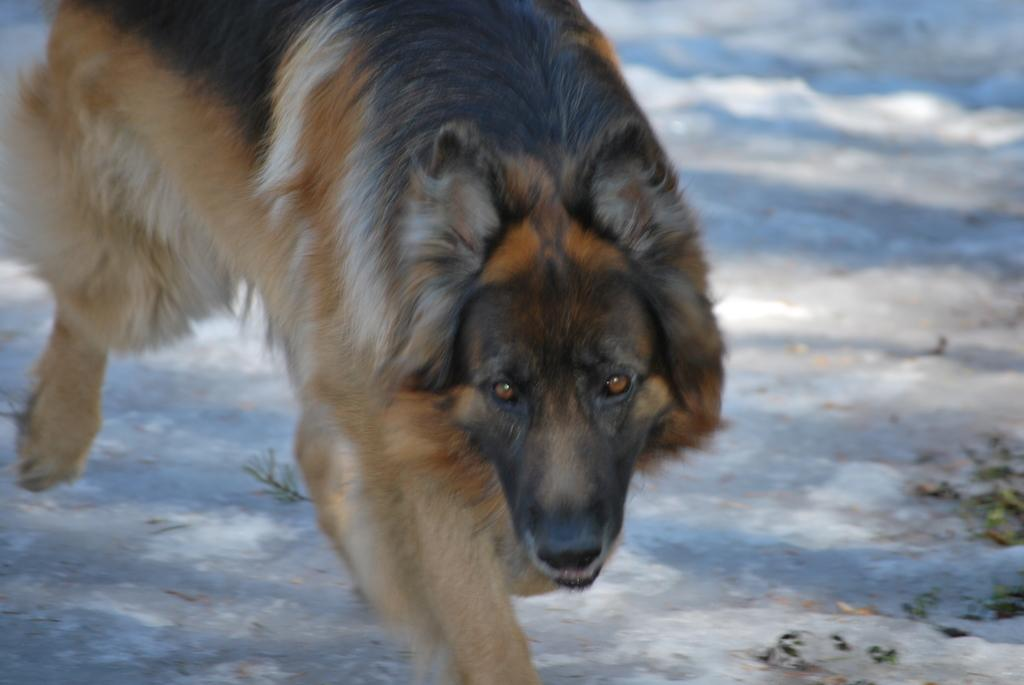What animal can be seen in the image? There is a dog in the image. What is the dog doing in the image? The dog is walking in the image. What type of environment is the dog in? The dog is in snow in the image. What type of flower can be seen in the image? There are no flowers present in the image; it features a dog walking in the snow. What letters are visible on the dog's collar in the image? The dog's collar is not visible in the image, so it is not possible to determine if there are any letters on it. 